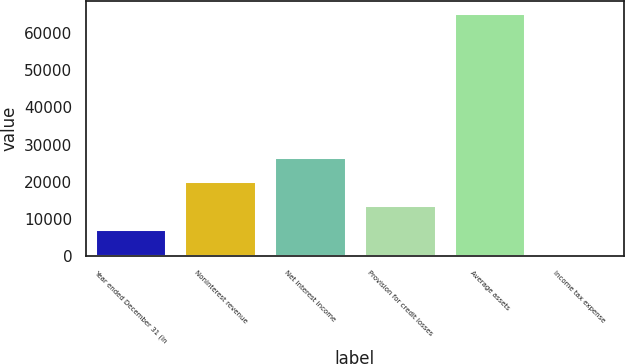<chart> <loc_0><loc_0><loc_500><loc_500><bar_chart><fcel>Year ended December 31 (in<fcel>Noninterest revenue<fcel>Net interest income<fcel>Provision for credit losses<fcel>Average assets<fcel>Income tax expense<nl><fcel>7340.2<fcel>20212.6<fcel>26648.8<fcel>13776.4<fcel>65266<fcel>904<nl></chart> 